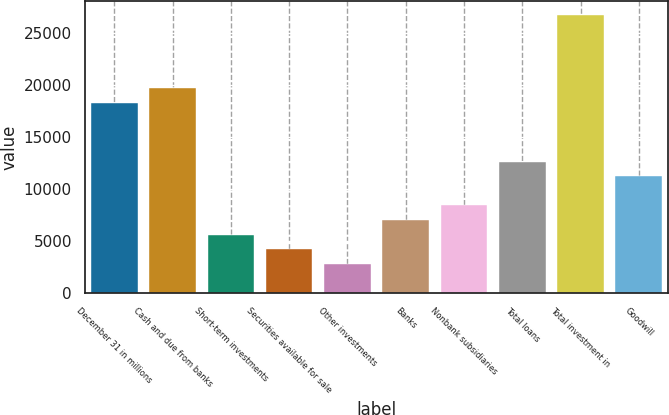<chart> <loc_0><loc_0><loc_500><loc_500><bar_chart><fcel>December 31 in millions<fcel>Cash and due from banks<fcel>Short-term investments<fcel>Securities available for sale<fcel>Other investments<fcel>Banks<fcel>Nonbank subsidiaries<fcel>Total loans<fcel>Total investment in<fcel>Goodwill<nl><fcel>18251.4<fcel>19655.2<fcel>5617.2<fcel>4213.4<fcel>2809.6<fcel>7021<fcel>8424.8<fcel>12636.2<fcel>26674.2<fcel>11232.4<nl></chart> 